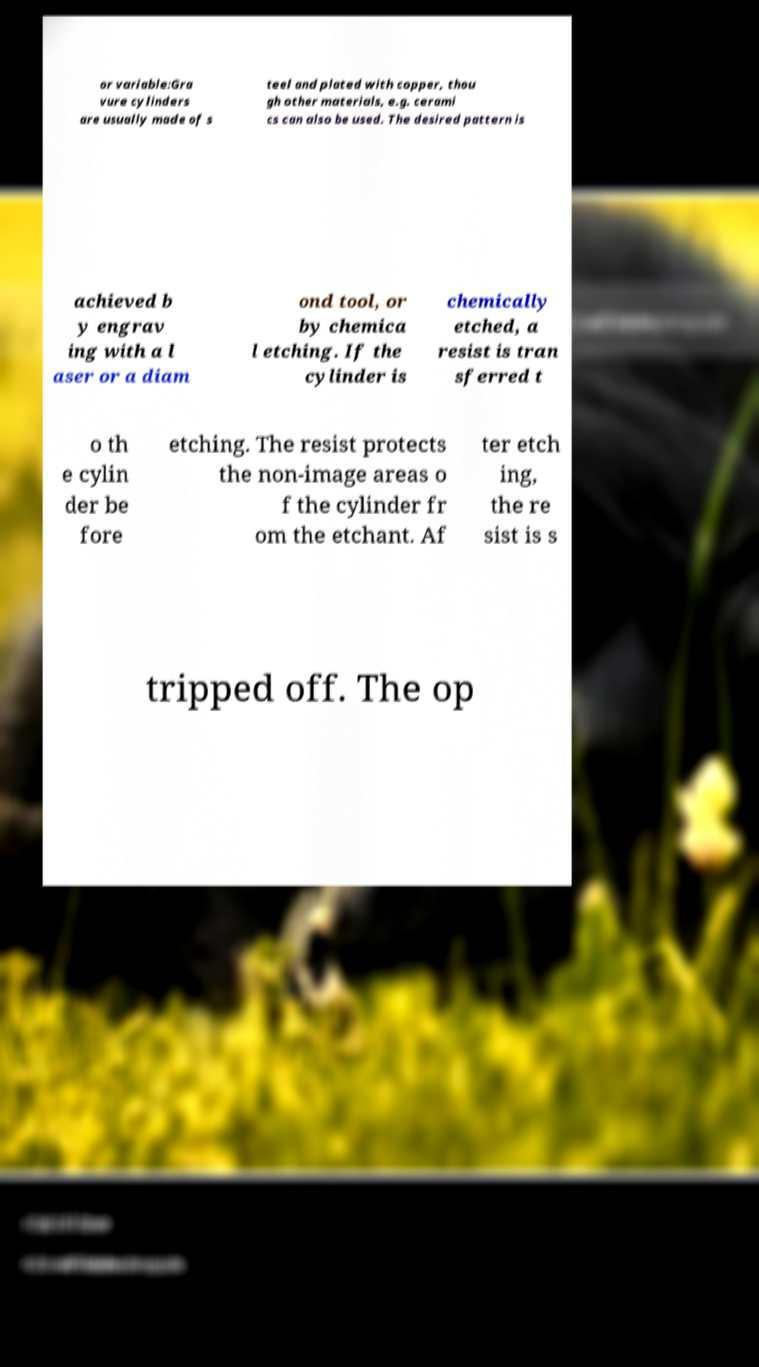I need the written content from this picture converted into text. Can you do that? or variable:Gra vure cylinders are usually made of s teel and plated with copper, thou gh other materials, e.g. cerami cs can also be used. The desired pattern is achieved b y engrav ing with a l aser or a diam ond tool, or by chemica l etching. If the cylinder is chemically etched, a resist is tran sferred t o th e cylin der be fore etching. The resist protects the non-image areas o f the cylinder fr om the etchant. Af ter etch ing, the re sist is s tripped off. The op 